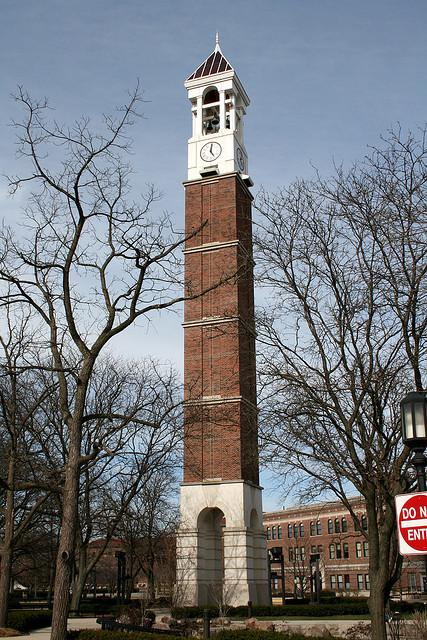How tall is the tower?
Quick response, please. 56ft. What time does the clock say?
Quick response, please. 5:00. What color is the tower?
Short answer required. Brown white. How tall is this building?
Quick response, please. Very tall. 